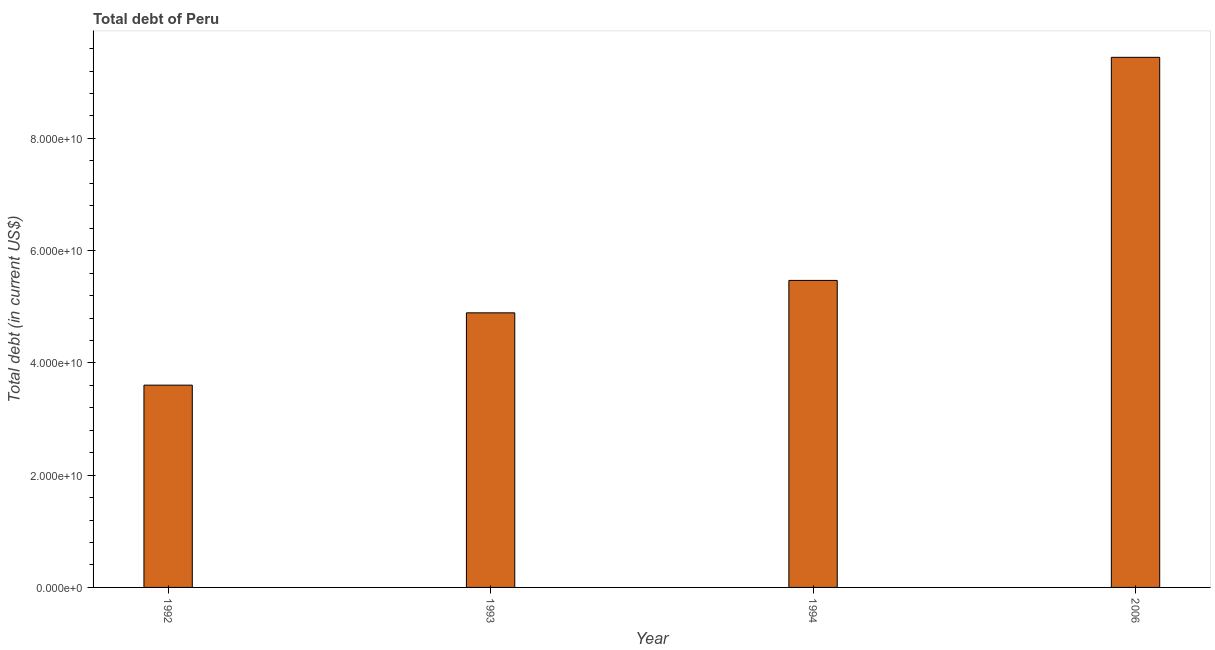Does the graph contain grids?
Provide a succinct answer. No. What is the title of the graph?
Your response must be concise. Total debt of Peru. What is the label or title of the X-axis?
Offer a very short reply. Year. What is the label or title of the Y-axis?
Your answer should be compact. Total debt (in current US$). What is the total debt in 1992?
Your response must be concise. 3.60e+1. Across all years, what is the maximum total debt?
Offer a very short reply. 9.45e+1. Across all years, what is the minimum total debt?
Your answer should be compact. 3.60e+1. In which year was the total debt minimum?
Make the answer very short. 1992. What is the sum of the total debt?
Provide a succinct answer. 2.34e+11. What is the difference between the total debt in 1994 and 2006?
Keep it short and to the point. -3.97e+1. What is the average total debt per year?
Your answer should be very brief. 5.85e+1. What is the median total debt?
Provide a succinct answer. 5.18e+1. In how many years, is the total debt greater than 28000000000 US$?
Offer a terse response. 4. Do a majority of the years between 1993 and 1992 (inclusive) have total debt greater than 44000000000 US$?
Keep it short and to the point. No. What is the ratio of the total debt in 1992 to that in 2006?
Provide a short and direct response. 0.38. Is the total debt in 1993 less than that in 1994?
Give a very brief answer. Yes. What is the difference between the highest and the second highest total debt?
Offer a terse response. 3.97e+1. What is the difference between the highest and the lowest total debt?
Make the answer very short. 5.84e+1. How many years are there in the graph?
Offer a terse response. 4. What is the difference between two consecutive major ticks on the Y-axis?
Ensure brevity in your answer.  2.00e+1. What is the Total debt (in current US$) in 1992?
Offer a very short reply. 3.60e+1. What is the Total debt (in current US$) in 1993?
Offer a very short reply. 4.89e+1. What is the Total debt (in current US$) of 1994?
Give a very brief answer. 5.47e+1. What is the Total debt (in current US$) in 2006?
Offer a very short reply. 9.45e+1. What is the difference between the Total debt (in current US$) in 1992 and 1993?
Ensure brevity in your answer.  -1.29e+1. What is the difference between the Total debt (in current US$) in 1992 and 1994?
Make the answer very short. -1.87e+1. What is the difference between the Total debt (in current US$) in 1992 and 2006?
Provide a succinct answer. -5.84e+1. What is the difference between the Total debt (in current US$) in 1993 and 1994?
Your answer should be very brief. -5.78e+09. What is the difference between the Total debt (in current US$) in 1993 and 2006?
Your answer should be compact. -4.55e+1. What is the difference between the Total debt (in current US$) in 1994 and 2006?
Provide a short and direct response. -3.97e+1. What is the ratio of the Total debt (in current US$) in 1992 to that in 1993?
Keep it short and to the point. 0.74. What is the ratio of the Total debt (in current US$) in 1992 to that in 1994?
Make the answer very short. 0.66. What is the ratio of the Total debt (in current US$) in 1992 to that in 2006?
Make the answer very short. 0.38. What is the ratio of the Total debt (in current US$) in 1993 to that in 1994?
Your response must be concise. 0.89. What is the ratio of the Total debt (in current US$) in 1993 to that in 2006?
Your answer should be very brief. 0.52. What is the ratio of the Total debt (in current US$) in 1994 to that in 2006?
Ensure brevity in your answer.  0.58. 